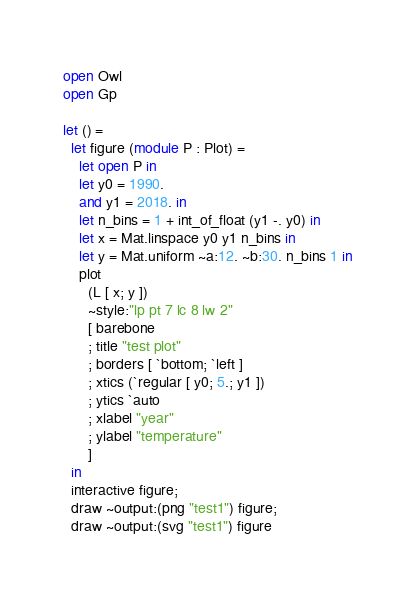<code> <loc_0><loc_0><loc_500><loc_500><_OCaml_>open Owl
open Gp

let () =
  let figure (module P : Plot) =
    let open P in
    let y0 = 1990.
    and y1 = 2018. in
    let n_bins = 1 + int_of_float (y1 -. y0) in
    let x = Mat.linspace y0 y1 n_bins in
    let y = Mat.uniform ~a:12. ~b:30. n_bins 1 in
    plot
      (L [ x; y ])
      ~style:"lp pt 7 lc 8 lw 2"
      [ barebone
      ; title "test plot"
      ; borders [ `bottom; `left ]
      ; xtics (`regular [ y0; 5.; y1 ])
      ; ytics `auto
      ; xlabel "year"
      ; ylabel "temperature"
      ]
  in
  interactive figure;
  draw ~output:(png "test1") figure;
  draw ~output:(svg "test1") figure
</code> 